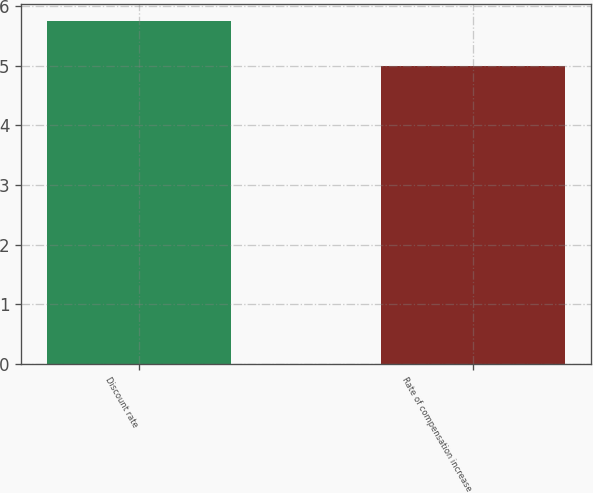Convert chart. <chart><loc_0><loc_0><loc_500><loc_500><bar_chart><fcel>Discount rate<fcel>Rate of compensation increase<nl><fcel>5.75<fcel>5<nl></chart> 